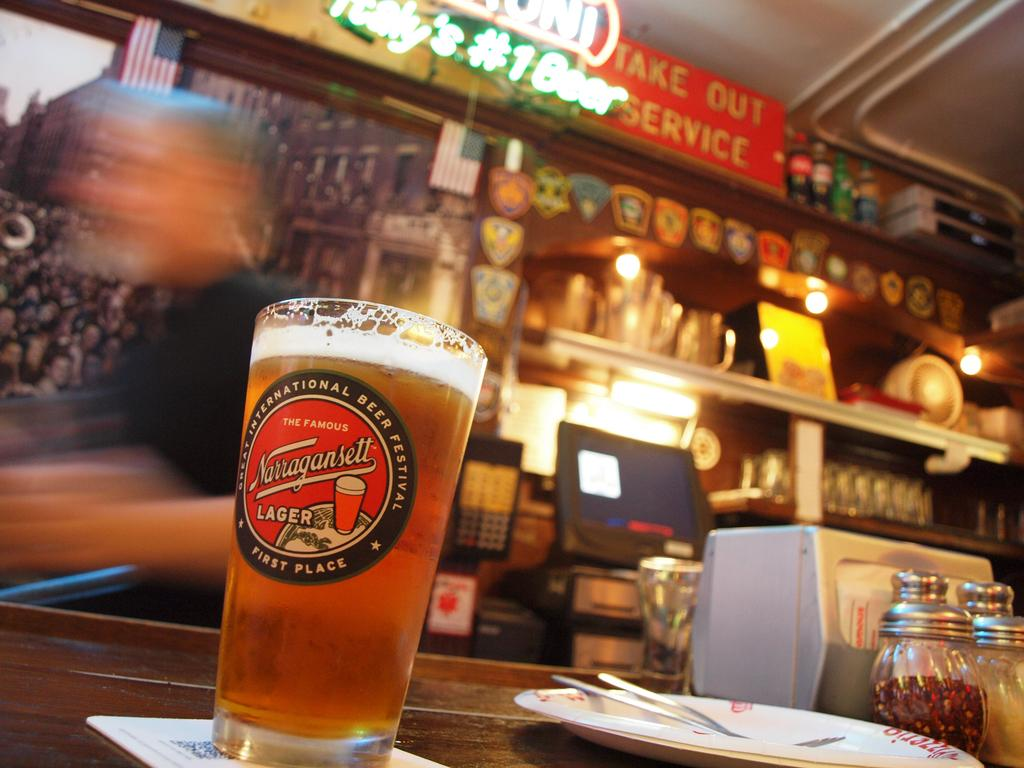Provide a one-sentence caption for the provided image. a beer glass from Narragansett is full sitting on the bar. 